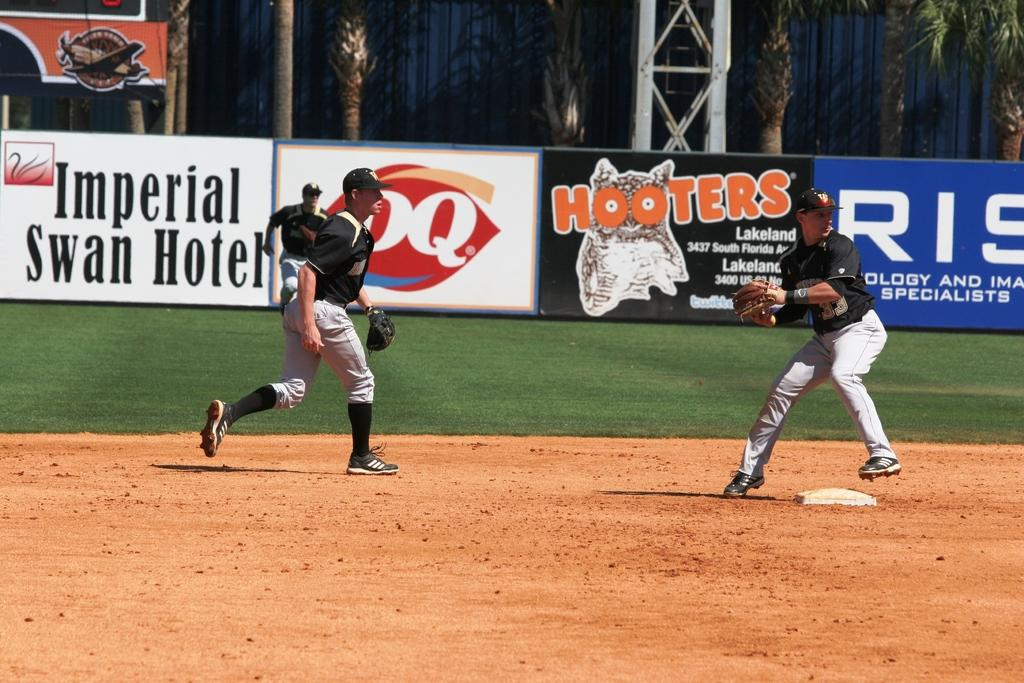<image>
Offer a succinct explanation of the picture presented. Hooters is one of the sponsors of this baseball field. 